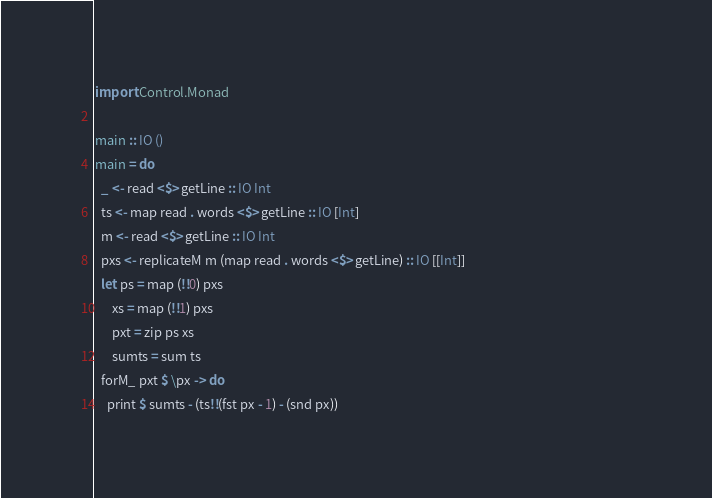<code> <loc_0><loc_0><loc_500><loc_500><_Haskell_>import Control.Monad                                                                                                       
                                                                                                                           
main :: IO ()                                                                                                              
main = do                                                                                                                  
  _ <- read <$> getLine :: IO Int                                                                                          
  ts <- map read . words <$> getLine :: IO [Int]                                                                           
  m <- read <$> getLine :: IO Int                                                                                          
  pxs <- replicateM m (map read . words <$> getLine) :: IO [[Int]]                                                         
  let ps = map (!!0) pxs                                                                                                   
      xs = map (!!1) pxs                                                                                                   
      pxt = zip ps xs                                                                                                      
      sumts = sum ts                                                                                                       
  forM_ pxt $ \px -> do                                                                                                    
    print $ sumts - (ts!!(fst px - 1) - (snd px))</code> 